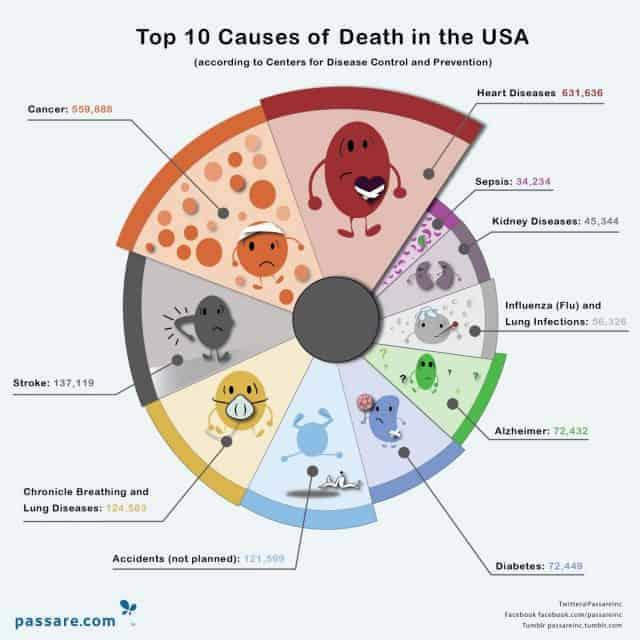Point out several critical features in this image. Deaths caused by cancer are lower than deaths caused by heart disease. The disease that is depicted in orange is cancer. The total number of deaths due to sepsis and Alzheimer's disease is 106,666. Alzheimer's disease is a condition that is depicted in green. 